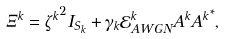<formula> <loc_0><loc_0><loc_500><loc_500>\Xi ^ { k } = { \zeta ^ { k } } ^ { 2 } I _ { S _ { k } } + \gamma _ { k } { \mathcal { E } } _ { A W G N } ^ { k } A ^ { k } { A ^ { k } } ^ { * } ,</formula> 